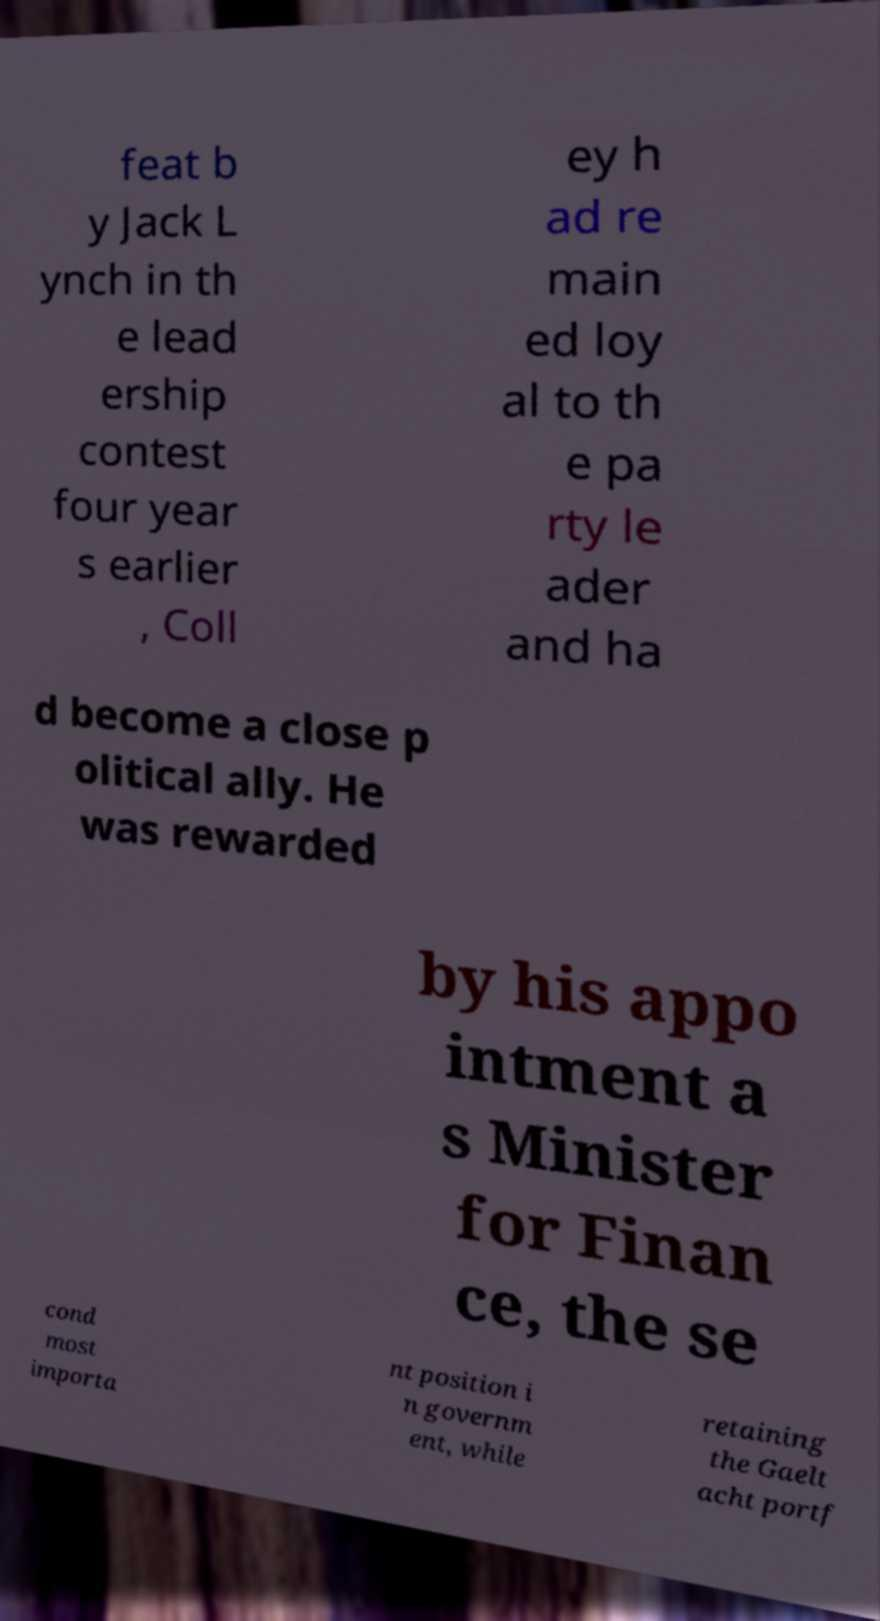Could you extract and type out the text from this image? feat b y Jack L ynch in th e lead ership contest four year s earlier , Coll ey h ad re main ed loy al to th e pa rty le ader and ha d become a close p olitical ally. He was rewarded by his appo intment a s Minister for Finan ce, the se cond most importa nt position i n governm ent, while retaining the Gaelt acht portf 